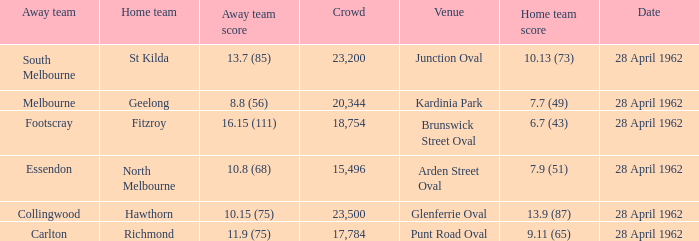At what venue did an away team score 10.15 (75)? Glenferrie Oval. 